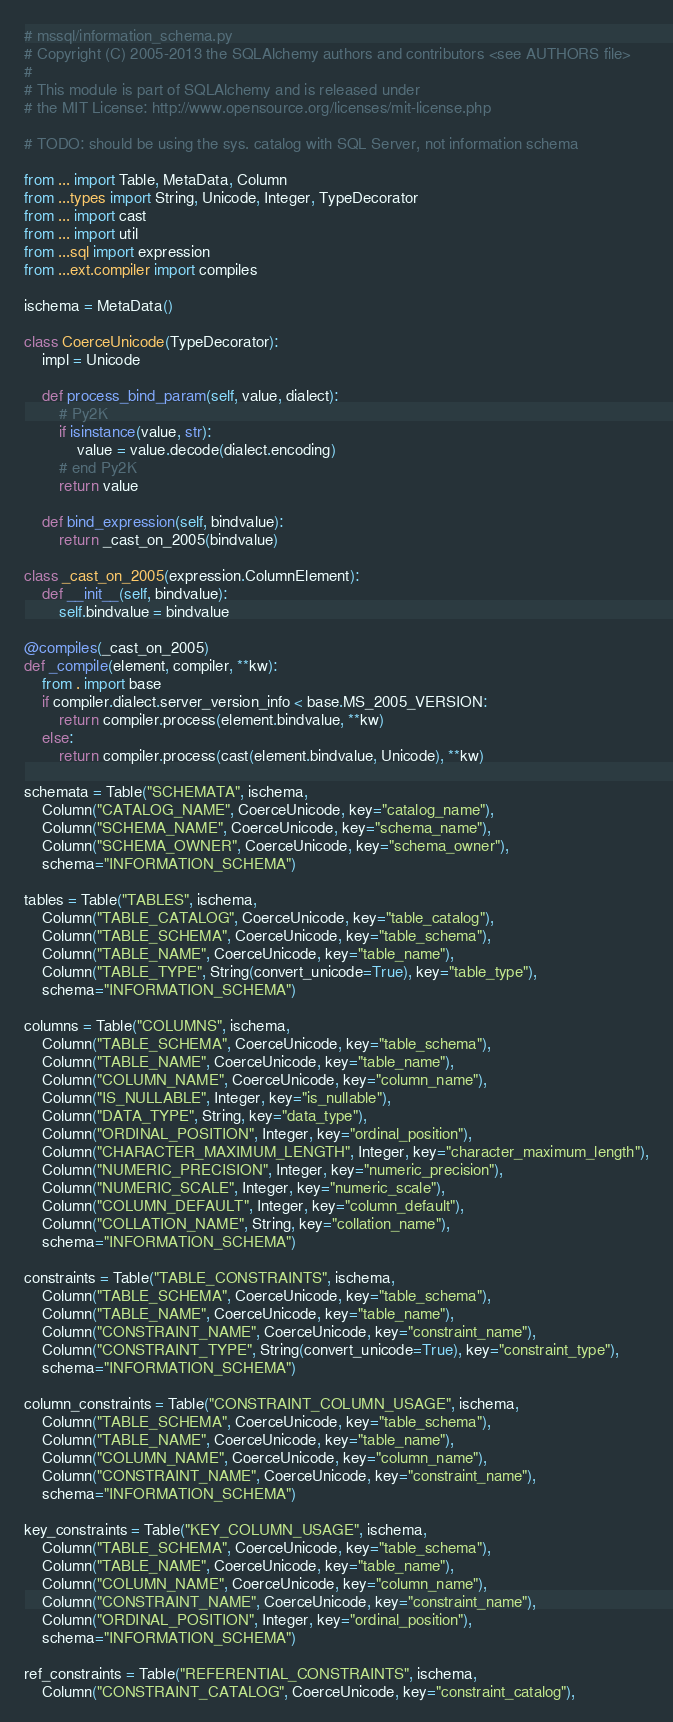<code> <loc_0><loc_0><loc_500><loc_500><_Python_># mssql/information_schema.py
# Copyright (C) 2005-2013 the SQLAlchemy authors and contributors <see AUTHORS file>
#
# This module is part of SQLAlchemy and is released under
# the MIT License: http://www.opensource.org/licenses/mit-license.php

# TODO: should be using the sys. catalog with SQL Server, not information schema

from ... import Table, MetaData, Column
from ...types import String, Unicode, Integer, TypeDecorator
from ... import cast
from ... import util
from ...sql import expression
from ...ext.compiler import compiles

ischema = MetaData()

class CoerceUnicode(TypeDecorator):
    impl = Unicode

    def process_bind_param(self, value, dialect):
        # Py2K
        if isinstance(value, str):
            value = value.decode(dialect.encoding)
        # end Py2K
        return value

    def bind_expression(self, bindvalue):
        return _cast_on_2005(bindvalue)

class _cast_on_2005(expression.ColumnElement):
    def __init__(self, bindvalue):
        self.bindvalue = bindvalue

@compiles(_cast_on_2005)
def _compile(element, compiler, **kw):
    from . import base
    if compiler.dialect.server_version_info < base.MS_2005_VERSION:
        return compiler.process(element.bindvalue, **kw)
    else:
        return compiler.process(cast(element.bindvalue, Unicode), **kw)

schemata = Table("SCHEMATA", ischema,
    Column("CATALOG_NAME", CoerceUnicode, key="catalog_name"),
    Column("SCHEMA_NAME", CoerceUnicode, key="schema_name"),
    Column("SCHEMA_OWNER", CoerceUnicode, key="schema_owner"),
    schema="INFORMATION_SCHEMA")

tables = Table("TABLES", ischema,
    Column("TABLE_CATALOG", CoerceUnicode, key="table_catalog"),
    Column("TABLE_SCHEMA", CoerceUnicode, key="table_schema"),
    Column("TABLE_NAME", CoerceUnicode, key="table_name"),
    Column("TABLE_TYPE", String(convert_unicode=True), key="table_type"),
    schema="INFORMATION_SCHEMA")

columns = Table("COLUMNS", ischema,
    Column("TABLE_SCHEMA", CoerceUnicode, key="table_schema"),
    Column("TABLE_NAME", CoerceUnicode, key="table_name"),
    Column("COLUMN_NAME", CoerceUnicode, key="column_name"),
    Column("IS_NULLABLE", Integer, key="is_nullable"),
    Column("DATA_TYPE", String, key="data_type"),
    Column("ORDINAL_POSITION", Integer, key="ordinal_position"),
    Column("CHARACTER_MAXIMUM_LENGTH", Integer, key="character_maximum_length"),
    Column("NUMERIC_PRECISION", Integer, key="numeric_precision"),
    Column("NUMERIC_SCALE", Integer, key="numeric_scale"),
    Column("COLUMN_DEFAULT", Integer, key="column_default"),
    Column("COLLATION_NAME", String, key="collation_name"),
    schema="INFORMATION_SCHEMA")

constraints = Table("TABLE_CONSTRAINTS", ischema,
    Column("TABLE_SCHEMA", CoerceUnicode, key="table_schema"),
    Column("TABLE_NAME", CoerceUnicode, key="table_name"),
    Column("CONSTRAINT_NAME", CoerceUnicode, key="constraint_name"),
    Column("CONSTRAINT_TYPE", String(convert_unicode=True), key="constraint_type"),
    schema="INFORMATION_SCHEMA")

column_constraints = Table("CONSTRAINT_COLUMN_USAGE", ischema,
    Column("TABLE_SCHEMA", CoerceUnicode, key="table_schema"),
    Column("TABLE_NAME", CoerceUnicode, key="table_name"),
    Column("COLUMN_NAME", CoerceUnicode, key="column_name"),
    Column("CONSTRAINT_NAME", CoerceUnicode, key="constraint_name"),
    schema="INFORMATION_SCHEMA")

key_constraints = Table("KEY_COLUMN_USAGE", ischema,
    Column("TABLE_SCHEMA", CoerceUnicode, key="table_schema"),
    Column("TABLE_NAME", CoerceUnicode, key="table_name"),
    Column("COLUMN_NAME", CoerceUnicode, key="column_name"),
    Column("CONSTRAINT_NAME", CoerceUnicode, key="constraint_name"),
    Column("ORDINAL_POSITION", Integer, key="ordinal_position"),
    schema="INFORMATION_SCHEMA")

ref_constraints = Table("REFERENTIAL_CONSTRAINTS", ischema,
    Column("CONSTRAINT_CATALOG", CoerceUnicode, key="constraint_catalog"),</code> 